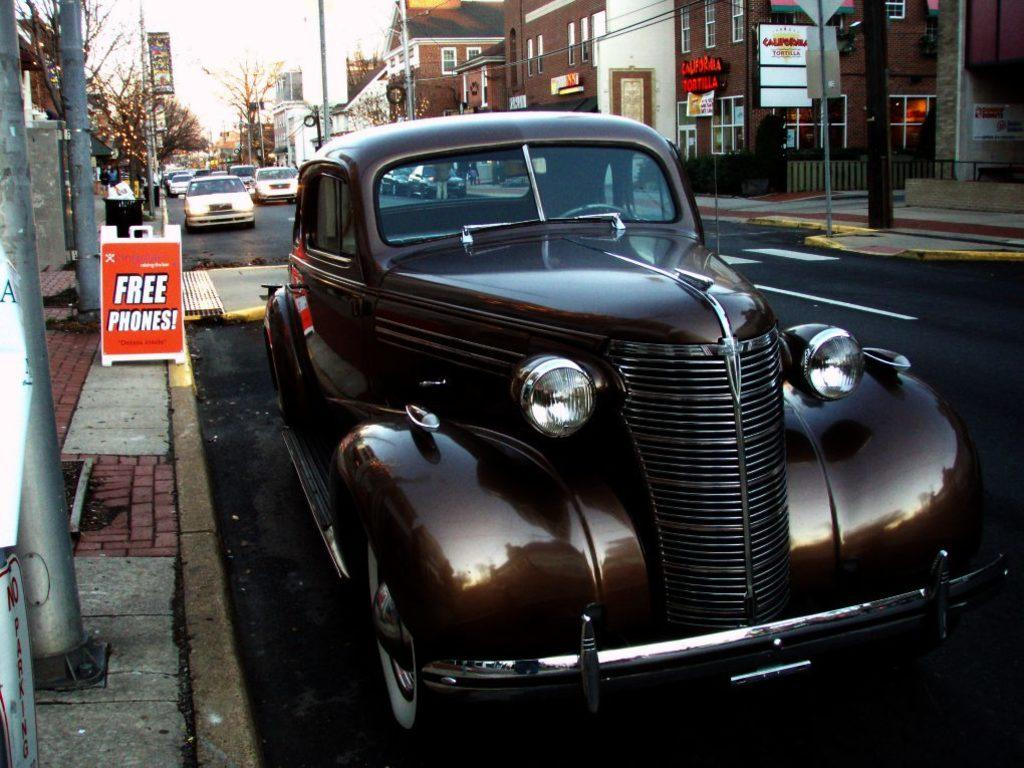Provide a one-sentence caption for the provided image. A classic car is parked on a city street next to a billboard for free phones. 